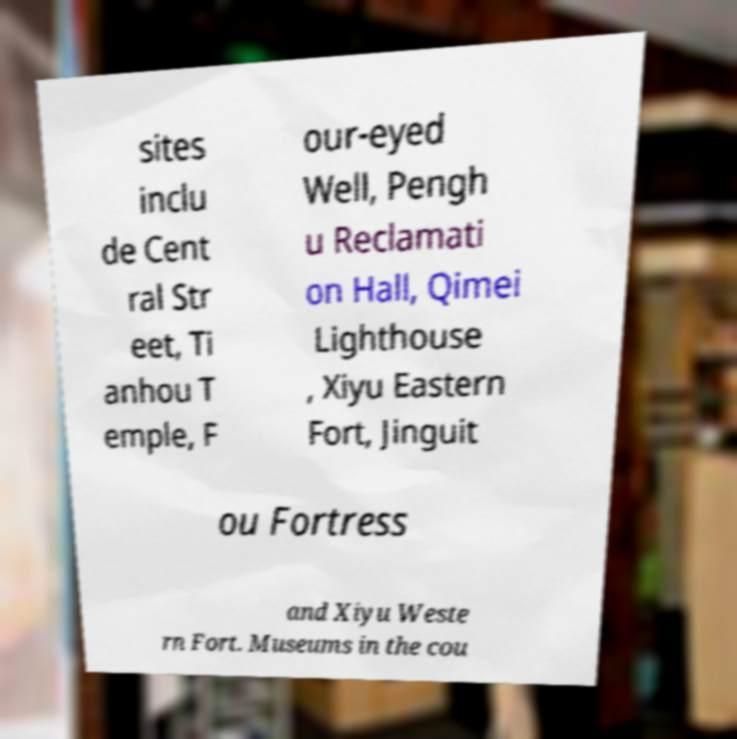Can you accurately transcribe the text from the provided image for me? sites inclu de Cent ral Str eet, Ti anhou T emple, F our-eyed Well, Pengh u Reclamati on Hall, Qimei Lighthouse , Xiyu Eastern Fort, Jinguit ou Fortress and Xiyu Weste rn Fort. Museums in the cou 